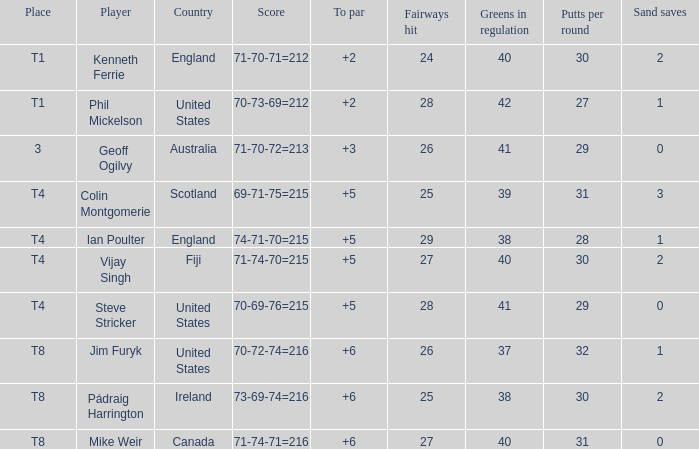What score to highest to par did Mike Weir achieve? 6.0. 